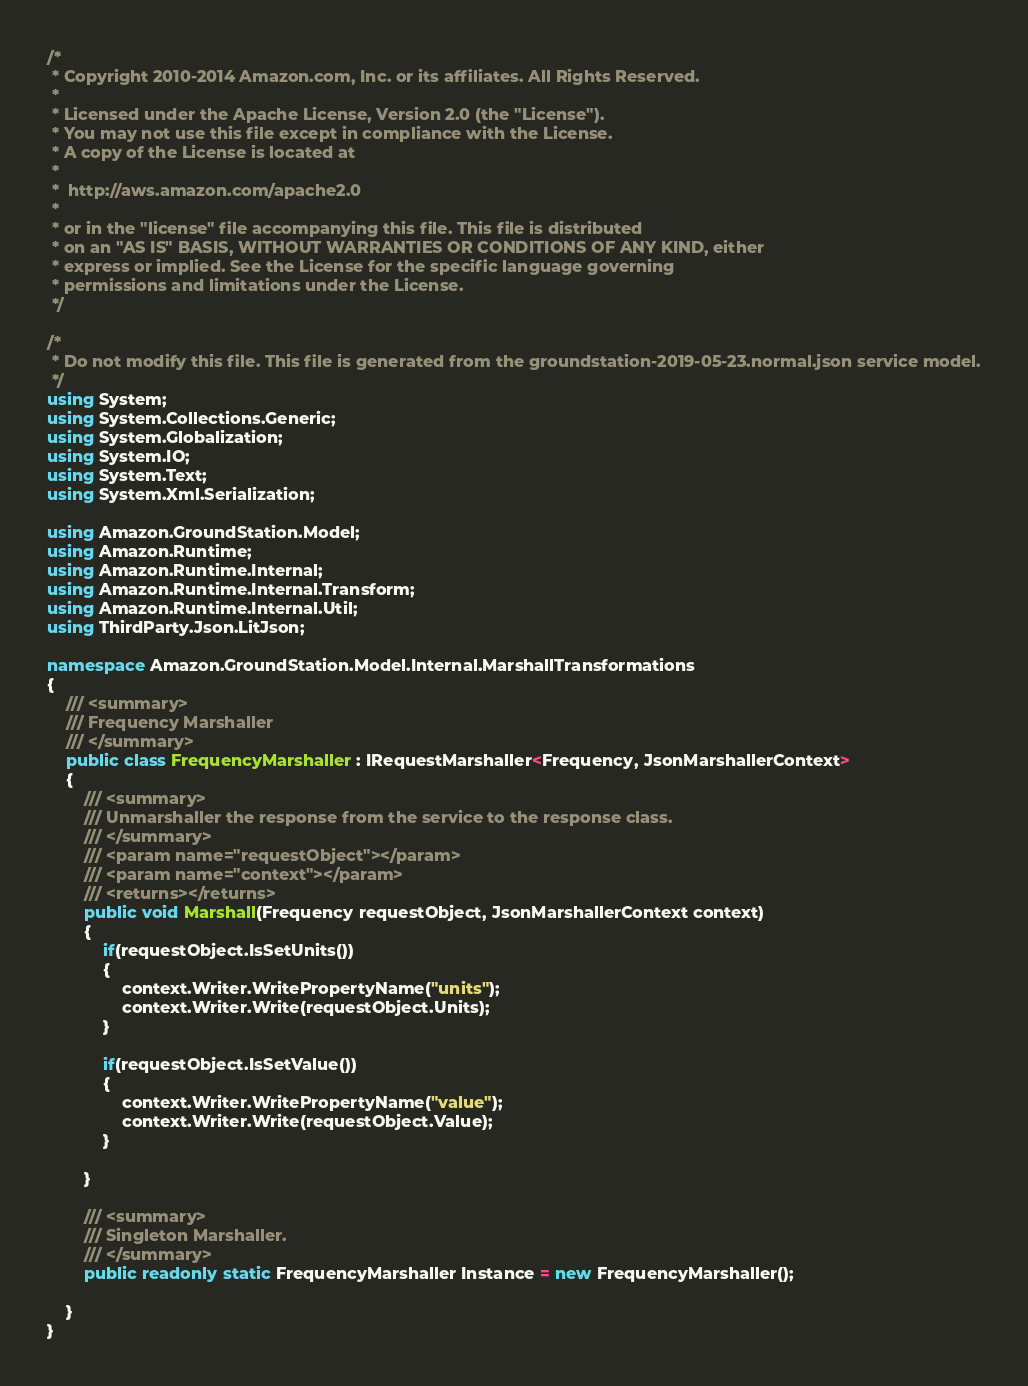Convert code to text. <code><loc_0><loc_0><loc_500><loc_500><_C#_>/*
 * Copyright 2010-2014 Amazon.com, Inc. or its affiliates. All Rights Reserved.
 * 
 * Licensed under the Apache License, Version 2.0 (the "License").
 * You may not use this file except in compliance with the License.
 * A copy of the License is located at
 * 
 *  http://aws.amazon.com/apache2.0
 * 
 * or in the "license" file accompanying this file. This file is distributed
 * on an "AS IS" BASIS, WITHOUT WARRANTIES OR CONDITIONS OF ANY KIND, either
 * express or implied. See the License for the specific language governing
 * permissions and limitations under the License.
 */

/*
 * Do not modify this file. This file is generated from the groundstation-2019-05-23.normal.json service model.
 */
using System;
using System.Collections.Generic;
using System.Globalization;
using System.IO;
using System.Text;
using System.Xml.Serialization;

using Amazon.GroundStation.Model;
using Amazon.Runtime;
using Amazon.Runtime.Internal;
using Amazon.Runtime.Internal.Transform;
using Amazon.Runtime.Internal.Util;
using ThirdParty.Json.LitJson;

namespace Amazon.GroundStation.Model.Internal.MarshallTransformations
{
    /// <summary>
    /// Frequency Marshaller
    /// </summary>       
    public class FrequencyMarshaller : IRequestMarshaller<Frequency, JsonMarshallerContext> 
    {
        /// <summary>
        /// Unmarshaller the response from the service to the response class.
        /// </summary>  
        /// <param name="requestObject"></param>
        /// <param name="context"></param>
        /// <returns></returns>
        public void Marshall(Frequency requestObject, JsonMarshallerContext context)
        {
            if(requestObject.IsSetUnits())
            {
                context.Writer.WritePropertyName("units");
                context.Writer.Write(requestObject.Units);
            }

            if(requestObject.IsSetValue())
            {
                context.Writer.WritePropertyName("value");
                context.Writer.Write(requestObject.Value);
            }

        }

        /// <summary>
        /// Singleton Marshaller.
        /// </summary>  
        public readonly static FrequencyMarshaller Instance = new FrequencyMarshaller();

    }
}</code> 